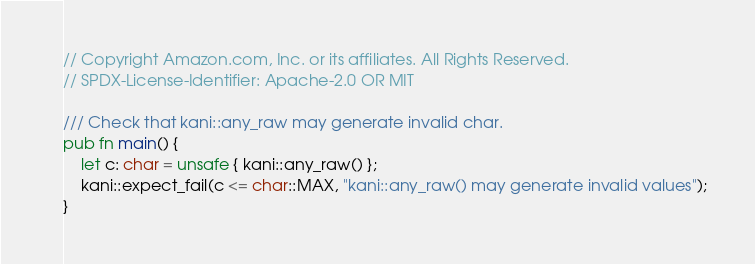Convert code to text. <code><loc_0><loc_0><loc_500><loc_500><_Rust_>// Copyright Amazon.com, Inc. or its affiliates. All Rights Reserved.
// SPDX-License-Identifier: Apache-2.0 OR MIT

/// Check that kani::any_raw may generate invalid char.
pub fn main() {
    let c: char = unsafe { kani::any_raw() };
    kani::expect_fail(c <= char::MAX, "kani::any_raw() may generate invalid values");
}
</code> 